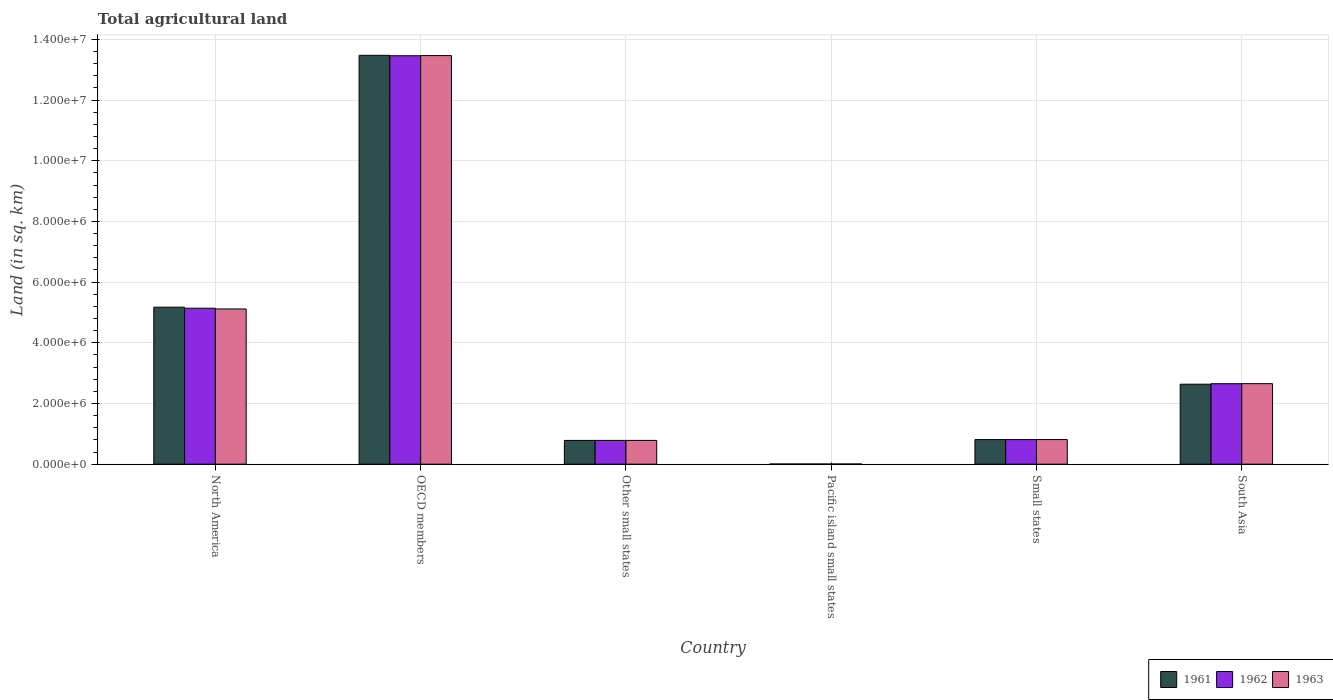How many different coloured bars are there?
Ensure brevity in your answer.  3. How many groups of bars are there?
Your response must be concise. 6. What is the label of the 2nd group of bars from the left?
Your response must be concise. OECD members. What is the total agricultural land in 1961 in South Asia?
Provide a short and direct response. 2.64e+06. Across all countries, what is the maximum total agricultural land in 1963?
Your answer should be compact. 1.35e+07. Across all countries, what is the minimum total agricultural land in 1962?
Your answer should be very brief. 5130. In which country was the total agricultural land in 1962 minimum?
Give a very brief answer. Pacific island small states. What is the total total agricultural land in 1963 in the graph?
Ensure brevity in your answer.  2.28e+07. What is the difference between the total agricultural land in 1962 in North America and that in Other small states?
Keep it short and to the point. 4.36e+06. What is the difference between the total agricultural land in 1962 in Small states and the total agricultural land in 1961 in OECD members?
Provide a succinct answer. -1.27e+07. What is the average total agricultural land in 1962 per country?
Your response must be concise. 3.81e+06. What is the difference between the total agricultural land of/in 1961 and total agricultural land of/in 1963 in North America?
Ensure brevity in your answer.  5.81e+04. In how many countries, is the total agricultural land in 1961 greater than 800000 sq.km?
Your response must be concise. 4. What is the ratio of the total agricultural land in 1961 in Pacific island small states to that in South Asia?
Your answer should be very brief. 0. Is the total agricultural land in 1962 in Pacific island small states less than that in South Asia?
Provide a succinct answer. Yes. What is the difference between the highest and the second highest total agricultural land in 1962?
Your response must be concise. -8.32e+06. What is the difference between the highest and the lowest total agricultural land in 1962?
Offer a very short reply. 1.35e+07. In how many countries, is the total agricultural land in 1961 greater than the average total agricultural land in 1961 taken over all countries?
Offer a very short reply. 2. What does the 1st bar from the left in South Asia represents?
Keep it short and to the point. 1961. Are the values on the major ticks of Y-axis written in scientific E-notation?
Your answer should be very brief. Yes. Does the graph contain any zero values?
Ensure brevity in your answer.  No. Where does the legend appear in the graph?
Make the answer very short. Bottom right. How many legend labels are there?
Your answer should be compact. 3. How are the legend labels stacked?
Give a very brief answer. Horizontal. What is the title of the graph?
Make the answer very short. Total agricultural land. What is the label or title of the Y-axis?
Ensure brevity in your answer.  Land (in sq. km). What is the Land (in sq. km) of 1961 in North America?
Your answer should be compact. 5.17e+06. What is the Land (in sq. km) of 1962 in North America?
Make the answer very short. 5.14e+06. What is the Land (in sq. km) in 1963 in North America?
Offer a very short reply. 5.12e+06. What is the Land (in sq. km) in 1961 in OECD members?
Provide a short and direct response. 1.35e+07. What is the Land (in sq. km) in 1962 in OECD members?
Your answer should be very brief. 1.35e+07. What is the Land (in sq. km) in 1963 in OECD members?
Give a very brief answer. 1.35e+07. What is the Land (in sq. km) in 1961 in Other small states?
Ensure brevity in your answer.  7.83e+05. What is the Land (in sq. km) of 1962 in Other small states?
Keep it short and to the point. 7.83e+05. What is the Land (in sq. km) in 1963 in Other small states?
Keep it short and to the point. 7.83e+05. What is the Land (in sq. km) of 1961 in Pacific island small states?
Offer a terse response. 5110. What is the Land (in sq. km) of 1962 in Pacific island small states?
Your response must be concise. 5130. What is the Land (in sq. km) of 1963 in Pacific island small states?
Provide a short and direct response. 5190. What is the Land (in sq. km) in 1961 in Small states?
Make the answer very short. 8.10e+05. What is the Land (in sq. km) in 1962 in Small states?
Make the answer very short. 8.11e+05. What is the Land (in sq. km) in 1963 in Small states?
Provide a short and direct response. 8.11e+05. What is the Land (in sq. km) of 1961 in South Asia?
Offer a very short reply. 2.64e+06. What is the Land (in sq. km) in 1962 in South Asia?
Keep it short and to the point. 2.65e+06. What is the Land (in sq. km) in 1963 in South Asia?
Ensure brevity in your answer.  2.65e+06. Across all countries, what is the maximum Land (in sq. km) in 1961?
Keep it short and to the point. 1.35e+07. Across all countries, what is the maximum Land (in sq. km) in 1962?
Make the answer very short. 1.35e+07. Across all countries, what is the maximum Land (in sq. km) of 1963?
Provide a short and direct response. 1.35e+07. Across all countries, what is the minimum Land (in sq. km) in 1961?
Your answer should be very brief. 5110. Across all countries, what is the minimum Land (in sq. km) of 1962?
Provide a short and direct response. 5130. Across all countries, what is the minimum Land (in sq. km) in 1963?
Offer a very short reply. 5190. What is the total Land (in sq. km) of 1961 in the graph?
Give a very brief answer. 2.29e+07. What is the total Land (in sq. km) of 1962 in the graph?
Offer a very short reply. 2.29e+07. What is the total Land (in sq. km) of 1963 in the graph?
Offer a terse response. 2.28e+07. What is the difference between the Land (in sq. km) in 1961 in North America and that in OECD members?
Your answer should be very brief. -8.30e+06. What is the difference between the Land (in sq. km) of 1962 in North America and that in OECD members?
Your answer should be very brief. -8.32e+06. What is the difference between the Land (in sq. km) in 1963 in North America and that in OECD members?
Your response must be concise. -8.35e+06. What is the difference between the Land (in sq. km) in 1961 in North America and that in Other small states?
Offer a very short reply. 4.39e+06. What is the difference between the Land (in sq. km) of 1962 in North America and that in Other small states?
Ensure brevity in your answer.  4.36e+06. What is the difference between the Land (in sq. km) in 1963 in North America and that in Other small states?
Your response must be concise. 4.33e+06. What is the difference between the Land (in sq. km) in 1961 in North America and that in Pacific island small states?
Provide a succinct answer. 5.17e+06. What is the difference between the Land (in sq. km) of 1962 in North America and that in Pacific island small states?
Offer a very short reply. 5.13e+06. What is the difference between the Land (in sq. km) of 1963 in North America and that in Pacific island small states?
Provide a short and direct response. 5.11e+06. What is the difference between the Land (in sq. km) in 1961 in North America and that in Small states?
Keep it short and to the point. 4.36e+06. What is the difference between the Land (in sq. km) of 1962 in North America and that in Small states?
Provide a short and direct response. 4.33e+06. What is the difference between the Land (in sq. km) in 1963 in North America and that in Small states?
Your answer should be very brief. 4.30e+06. What is the difference between the Land (in sq. km) in 1961 in North America and that in South Asia?
Offer a very short reply. 2.54e+06. What is the difference between the Land (in sq. km) of 1962 in North America and that in South Asia?
Your response must be concise. 2.49e+06. What is the difference between the Land (in sq. km) in 1963 in North America and that in South Asia?
Your answer should be very brief. 2.46e+06. What is the difference between the Land (in sq. km) in 1961 in OECD members and that in Other small states?
Make the answer very short. 1.27e+07. What is the difference between the Land (in sq. km) in 1962 in OECD members and that in Other small states?
Give a very brief answer. 1.27e+07. What is the difference between the Land (in sq. km) of 1963 in OECD members and that in Other small states?
Your answer should be very brief. 1.27e+07. What is the difference between the Land (in sq. km) in 1961 in OECD members and that in Pacific island small states?
Make the answer very short. 1.35e+07. What is the difference between the Land (in sq. km) of 1962 in OECD members and that in Pacific island small states?
Keep it short and to the point. 1.35e+07. What is the difference between the Land (in sq. km) of 1963 in OECD members and that in Pacific island small states?
Provide a succinct answer. 1.35e+07. What is the difference between the Land (in sq. km) in 1961 in OECD members and that in Small states?
Ensure brevity in your answer.  1.27e+07. What is the difference between the Land (in sq. km) in 1962 in OECD members and that in Small states?
Provide a short and direct response. 1.27e+07. What is the difference between the Land (in sq. km) in 1963 in OECD members and that in Small states?
Provide a short and direct response. 1.27e+07. What is the difference between the Land (in sq. km) of 1961 in OECD members and that in South Asia?
Your answer should be compact. 1.08e+07. What is the difference between the Land (in sq. km) in 1962 in OECD members and that in South Asia?
Give a very brief answer. 1.08e+07. What is the difference between the Land (in sq. km) in 1963 in OECD members and that in South Asia?
Provide a short and direct response. 1.08e+07. What is the difference between the Land (in sq. km) in 1961 in Other small states and that in Pacific island small states?
Offer a very short reply. 7.78e+05. What is the difference between the Land (in sq. km) of 1962 in Other small states and that in Pacific island small states?
Offer a very short reply. 7.78e+05. What is the difference between the Land (in sq. km) in 1963 in Other small states and that in Pacific island small states?
Provide a succinct answer. 7.78e+05. What is the difference between the Land (in sq. km) in 1961 in Other small states and that in Small states?
Offer a very short reply. -2.74e+04. What is the difference between the Land (in sq. km) in 1962 in Other small states and that in Small states?
Your response must be concise. -2.75e+04. What is the difference between the Land (in sq. km) in 1963 in Other small states and that in Small states?
Your answer should be compact. -2.76e+04. What is the difference between the Land (in sq. km) of 1961 in Other small states and that in South Asia?
Offer a terse response. -1.85e+06. What is the difference between the Land (in sq. km) of 1962 in Other small states and that in South Asia?
Make the answer very short. -1.87e+06. What is the difference between the Land (in sq. km) of 1963 in Other small states and that in South Asia?
Offer a terse response. -1.87e+06. What is the difference between the Land (in sq. km) of 1961 in Pacific island small states and that in Small states?
Your response must be concise. -8.05e+05. What is the difference between the Land (in sq. km) of 1962 in Pacific island small states and that in Small states?
Ensure brevity in your answer.  -8.05e+05. What is the difference between the Land (in sq. km) in 1963 in Pacific island small states and that in Small states?
Your answer should be compact. -8.06e+05. What is the difference between the Land (in sq. km) of 1961 in Pacific island small states and that in South Asia?
Your answer should be very brief. -2.63e+06. What is the difference between the Land (in sq. km) of 1962 in Pacific island small states and that in South Asia?
Your answer should be compact. -2.65e+06. What is the difference between the Land (in sq. km) of 1963 in Pacific island small states and that in South Asia?
Offer a terse response. -2.65e+06. What is the difference between the Land (in sq. km) in 1961 in Small states and that in South Asia?
Your answer should be compact. -1.82e+06. What is the difference between the Land (in sq. km) of 1962 in Small states and that in South Asia?
Ensure brevity in your answer.  -1.84e+06. What is the difference between the Land (in sq. km) of 1963 in Small states and that in South Asia?
Ensure brevity in your answer.  -1.84e+06. What is the difference between the Land (in sq. km) of 1961 in North America and the Land (in sq. km) of 1962 in OECD members?
Your response must be concise. -8.29e+06. What is the difference between the Land (in sq. km) of 1961 in North America and the Land (in sq. km) of 1963 in OECD members?
Provide a succinct answer. -8.29e+06. What is the difference between the Land (in sq. km) of 1962 in North America and the Land (in sq. km) of 1963 in OECD members?
Your response must be concise. -8.33e+06. What is the difference between the Land (in sq. km) in 1961 in North America and the Land (in sq. km) in 1962 in Other small states?
Keep it short and to the point. 4.39e+06. What is the difference between the Land (in sq. km) of 1961 in North America and the Land (in sq. km) of 1963 in Other small states?
Keep it short and to the point. 4.39e+06. What is the difference between the Land (in sq. km) in 1962 in North America and the Land (in sq. km) in 1963 in Other small states?
Your answer should be compact. 4.36e+06. What is the difference between the Land (in sq. km) of 1961 in North America and the Land (in sq. km) of 1962 in Pacific island small states?
Offer a very short reply. 5.17e+06. What is the difference between the Land (in sq. km) in 1961 in North America and the Land (in sq. km) in 1963 in Pacific island small states?
Your answer should be very brief. 5.17e+06. What is the difference between the Land (in sq. km) of 1962 in North America and the Land (in sq. km) of 1963 in Pacific island small states?
Provide a short and direct response. 5.13e+06. What is the difference between the Land (in sq. km) of 1961 in North America and the Land (in sq. km) of 1962 in Small states?
Your response must be concise. 4.36e+06. What is the difference between the Land (in sq. km) in 1961 in North America and the Land (in sq. km) in 1963 in Small states?
Make the answer very short. 4.36e+06. What is the difference between the Land (in sq. km) in 1962 in North America and the Land (in sq. km) in 1963 in Small states?
Offer a terse response. 4.33e+06. What is the difference between the Land (in sq. km) of 1961 in North America and the Land (in sq. km) of 1962 in South Asia?
Offer a terse response. 2.52e+06. What is the difference between the Land (in sq. km) in 1961 in North America and the Land (in sq. km) in 1963 in South Asia?
Offer a terse response. 2.52e+06. What is the difference between the Land (in sq. km) of 1962 in North America and the Land (in sq. km) of 1963 in South Asia?
Keep it short and to the point. 2.49e+06. What is the difference between the Land (in sq. km) of 1961 in OECD members and the Land (in sq. km) of 1962 in Other small states?
Provide a succinct answer. 1.27e+07. What is the difference between the Land (in sq. km) in 1961 in OECD members and the Land (in sq. km) in 1963 in Other small states?
Keep it short and to the point. 1.27e+07. What is the difference between the Land (in sq. km) of 1962 in OECD members and the Land (in sq. km) of 1963 in Other small states?
Your answer should be very brief. 1.27e+07. What is the difference between the Land (in sq. km) in 1961 in OECD members and the Land (in sq. km) in 1962 in Pacific island small states?
Offer a very short reply. 1.35e+07. What is the difference between the Land (in sq. km) of 1961 in OECD members and the Land (in sq. km) of 1963 in Pacific island small states?
Your answer should be compact. 1.35e+07. What is the difference between the Land (in sq. km) in 1962 in OECD members and the Land (in sq. km) in 1963 in Pacific island small states?
Your answer should be compact. 1.35e+07. What is the difference between the Land (in sq. km) of 1961 in OECD members and the Land (in sq. km) of 1962 in Small states?
Give a very brief answer. 1.27e+07. What is the difference between the Land (in sq. km) in 1961 in OECD members and the Land (in sq. km) in 1963 in Small states?
Make the answer very short. 1.27e+07. What is the difference between the Land (in sq. km) in 1962 in OECD members and the Land (in sq. km) in 1963 in Small states?
Ensure brevity in your answer.  1.27e+07. What is the difference between the Land (in sq. km) of 1961 in OECD members and the Land (in sq. km) of 1962 in South Asia?
Offer a terse response. 1.08e+07. What is the difference between the Land (in sq. km) of 1961 in OECD members and the Land (in sq. km) of 1963 in South Asia?
Your answer should be very brief. 1.08e+07. What is the difference between the Land (in sq. km) in 1962 in OECD members and the Land (in sq. km) in 1963 in South Asia?
Make the answer very short. 1.08e+07. What is the difference between the Land (in sq. km) in 1961 in Other small states and the Land (in sq. km) in 1962 in Pacific island small states?
Provide a short and direct response. 7.78e+05. What is the difference between the Land (in sq. km) in 1961 in Other small states and the Land (in sq. km) in 1963 in Pacific island small states?
Give a very brief answer. 7.78e+05. What is the difference between the Land (in sq. km) in 1962 in Other small states and the Land (in sq. km) in 1963 in Pacific island small states?
Keep it short and to the point. 7.78e+05. What is the difference between the Land (in sq. km) in 1961 in Other small states and the Land (in sq. km) in 1962 in Small states?
Your answer should be very brief. -2.78e+04. What is the difference between the Land (in sq. km) of 1961 in Other small states and the Land (in sq. km) of 1963 in Small states?
Offer a very short reply. -2.80e+04. What is the difference between the Land (in sq. km) in 1962 in Other small states and the Land (in sq. km) in 1963 in Small states?
Provide a short and direct response. -2.78e+04. What is the difference between the Land (in sq. km) in 1961 in Other small states and the Land (in sq. km) in 1962 in South Asia?
Ensure brevity in your answer.  -1.87e+06. What is the difference between the Land (in sq. km) in 1961 in Other small states and the Land (in sq. km) in 1963 in South Asia?
Your response must be concise. -1.87e+06. What is the difference between the Land (in sq. km) of 1962 in Other small states and the Land (in sq. km) of 1963 in South Asia?
Give a very brief answer. -1.87e+06. What is the difference between the Land (in sq. km) of 1961 in Pacific island small states and the Land (in sq. km) of 1962 in Small states?
Your answer should be compact. -8.05e+05. What is the difference between the Land (in sq. km) of 1961 in Pacific island small states and the Land (in sq. km) of 1963 in Small states?
Your response must be concise. -8.06e+05. What is the difference between the Land (in sq. km) of 1962 in Pacific island small states and the Land (in sq. km) of 1963 in Small states?
Provide a succinct answer. -8.06e+05. What is the difference between the Land (in sq. km) of 1961 in Pacific island small states and the Land (in sq. km) of 1962 in South Asia?
Provide a short and direct response. -2.65e+06. What is the difference between the Land (in sq. km) of 1961 in Pacific island small states and the Land (in sq. km) of 1963 in South Asia?
Provide a succinct answer. -2.65e+06. What is the difference between the Land (in sq. km) of 1962 in Pacific island small states and the Land (in sq. km) of 1963 in South Asia?
Keep it short and to the point. -2.65e+06. What is the difference between the Land (in sq. km) of 1961 in Small states and the Land (in sq. km) of 1962 in South Asia?
Provide a short and direct response. -1.84e+06. What is the difference between the Land (in sq. km) of 1961 in Small states and the Land (in sq. km) of 1963 in South Asia?
Your answer should be compact. -1.84e+06. What is the difference between the Land (in sq. km) in 1962 in Small states and the Land (in sq. km) in 1963 in South Asia?
Your answer should be compact. -1.84e+06. What is the average Land (in sq. km) in 1961 per country?
Your response must be concise. 3.81e+06. What is the average Land (in sq. km) of 1962 per country?
Ensure brevity in your answer.  3.81e+06. What is the average Land (in sq. km) of 1963 per country?
Offer a very short reply. 3.81e+06. What is the difference between the Land (in sq. km) in 1961 and Land (in sq. km) in 1962 in North America?
Make the answer very short. 3.39e+04. What is the difference between the Land (in sq. km) in 1961 and Land (in sq. km) in 1963 in North America?
Your response must be concise. 5.81e+04. What is the difference between the Land (in sq. km) in 1962 and Land (in sq. km) in 1963 in North America?
Your answer should be compact. 2.42e+04. What is the difference between the Land (in sq. km) in 1961 and Land (in sq. km) in 1962 in OECD members?
Your answer should be compact. 1.42e+04. What is the difference between the Land (in sq. km) of 1961 and Land (in sq. km) of 1963 in OECD members?
Your answer should be very brief. 8693. What is the difference between the Land (in sq. km) of 1962 and Land (in sq. km) of 1963 in OECD members?
Make the answer very short. -5492. What is the difference between the Land (in sq. km) of 1961 and Land (in sq. km) of 1962 in Other small states?
Offer a very short reply. -290. What is the difference between the Land (in sq. km) of 1961 and Land (in sq. km) of 1963 in Other small states?
Provide a short and direct response. -460. What is the difference between the Land (in sq. km) of 1962 and Land (in sq. km) of 1963 in Other small states?
Ensure brevity in your answer.  -170. What is the difference between the Land (in sq. km) in 1961 and Land (in sq. km) in 1962 in Pacific island small states?
Make the answer very short. -20. What is the difference between the Land (in sq. km) of 1961 and Land (in sq. km) of 1963 in Pacific island small states?
Offer a terse response. -80. What is the difference between the Land (in sq. km) of 1962 and Land (in sq. km) of 1963 in Pacific island small states?
Your answer should be compact. -60. What is the difference between the Land (in sq. km) in 1961 and Land (in sq. km) in 1962 in Small states?
Keep it short and to the point. -340. What is the difference between the Land (in sq. km) of 1961 and Land (in sq. km) of 1963 in Small states?
Provide a short and direct response. -600. What is the difference between the Land (in sq. km) of 1962 and Land (in sq. km) of 1963 in Small states?
Your answer should be compact. -260. What is the difference between the Land (in sq. km) in 1961 and Land (in sq. km) in 1962 in South Asia?
Offer a terse response. -1.68e+04. What is the difference between the Land (in sq. km) of 1961 and Land (in sq. km) of 1963 in South Asia?
Keep it short and to the point. -1.81e+04. What is the difference between the Land (in sq. km) in 1962 and Land (in sq. km) in 1963 in South Asia?
Provide a succinct answer. -1280. What is the ratio of the Land (in sq. km) in 1961 in North America to that in OECD members?
Your answer should be compact. 0.38. What is the ratio of the Land (in sq. km) in 1962 in North America to that in OECD members?
Your answer should be very brief. 0.38. What is the ratio of the Land (in sq. km) of 1963 in North America to that in OECD members?
Your answer should be compact. 0.38. What is the ratio of the Land (in sq. km) of 1961 in North America to that in Other small states?
Offer a terse response. 6.61. What is the ratio of the Land (in sq. km) in 1962 in North America to that in Other small states?
Make the answer very short. 6.56. What is the ratio of the Land (in sq. km) in 1963 in North America to that in Other small states?
Offer a very short reply. 6.53. What is the ratio of the Land (in sq. km) of 1961 in North America to that in Pacific island small states?
Give a very brief answer. 1012.4. What is the ratio of the Land (in sq. km) in 1962 in North America to that in Pacific island small states?
Your response must be concise. 1001.84. What is the ratio of the Land (in sq. km) in 1963 in North America to that in Pacific island small states?
Ensure brevity in your answer.  985.6. What is the ratio of the Land (in sq. km) of 1961 in North America to that in Small states?
Provide a short and direct response. 6.38. What is the ratio of the Land (in sq. km) of 1962 in North America to that in Small states?
Your answer should be compact. 6.34. What is the ratio of the Land (in sq. km) in 1963 in North America to that in Small states?
Your answer should be very brief. 6.31. What is the ratio of the Land (in sq. km) of 1961 in North America to that in South Asia?
Offer a very short reply. 1.96. What is the ratio of the Land (in sq. km) in 1962 in North America to that in South Asia?
Your answer should be very brief. 1.94. What is the ratio of the Land (in sq. km) of 1963 in North America to that in South Asia?
Give a very brief answer. 1.93. What is the ratio of the Land (in sq. km) in 1961 in OECD members to that in Other small states?
Give a very brief answer. 17.21. What is the ratio of the Land (in sq. km) of 1962 in OECD members to that in Other small states?
Your answer should be compact. 17.19. What is the ratio of the Land (in sq. km) of 1963 in OECD members to that in Other small states?
Provide a succinct answer. 17.19. What is the ratio of the Land (in sq. km) of 1961 in OECD members to that in Pacific island small states?
Provide a short and direct response. 2637.03. What is the ratio of the Land (in sq. km) of 1962 in OECD members to that in Pacific island small states?
Keep it short and to the point. 2623.99. What is the ratio of the Land (in sq. km) of 1963 in OECD members to that in Pacific island small states?
Offer a terse response. 2594.71. What is the ratio of the Land (in sq. km) of 1961 in OECD members to that in Small states?
Keep it short and to the point. 16.63. What is the ratio of the Land (in sq. km) in 1962 in OECD members to that in Small states?
Keep it short and to the point. 16.61. What is the ratio of the Land (in sq. km) of 1963 in OECD members to that in Small states?
Ensure brevity in your answer.  16.61. What is the ratio of the Land (in sq. km) in 1961 in OECD members to that in South Asia?
Provide a short and direct response. 5.11. What is the ratio of the Land (in sq. km) in 1962 in OECD members to that in South Asia?
Make the answer very short. 5.08. What is the ratio of the Land (in sq. km) of 1963 in OECD members to that in South Asia?
Ensure brevity in your answer.  5.08. What is the ratio of the Land (in sq. km) in 1961 in Other small states to that in Pacific island small states?
Give a very brief answer. 153.19. What is the ratio of the Land (in sq. km) of 1962 in Other small states to that in Pacific island small states?
Provide a short and direct response. 152.65. What is the ratio of the Land (in sq. km) in 1963 in Other small states to that in Pacific island small states?
Give a very brief answer. 150.91. What is the ratio of the Land (in sq. km) of 1961 in Other small states to that in Small states?
Ensure brevity in your answer.  0.97. What is the ratio of the Land (in sq. km) in 1962 in Other small states to that in Small states?
Your response must be concise. 0.97. What is the ratio of the Land (in sq. km) in 1961 in Other small states to that in South Asia?
Provide a succinct answer. 0.3. What is the ratio of the Land (in sq. km) in 1962 in Other small states to that in South Asia?
Ensure brevity in your answer.  0.3. What is the ratio of the Land (in sq. km) of 1963 in Other small states to that in South Asia?
Make the answer very short. 0.3. What is the ratio of the Land (in sq. km) of 1961 in Pacific island small states to that in Small states?
Keep it short and to the point. 0.01. What is the ratio of the Land (in sq. km) in 1962 in Pacific island small states to that in Small states?
Keep it short and to the point. 0.01. What is the ratio of the Land (in sq. km) of 1963 in Pacific island small states to that in Small states?
Your answer should be compact. 0.01. What is the ratio of the Land (in sq. km) in 1961 in Pacific island small states to that in South Asia?
Provide a succinct answer. 0. What is the ratio of the Land (in sq. km) of 1962 in Pacific island small states to that in South Asia?
Keep it short and to the point. 0. What is the ratio of the Land (in sq. km) of 1963 in Pacific island small states to that in South Asia?
Make the answer very short. 0. What is the ratio of the Land (in sq. km) in 1961 in Small states to that in South Asia?
Your answer should be very brief. 0.31. What is the ratio of the Land (in sq. km) in 1962 in Small states to that in South Asia?
Provide a short and direct response. 0.31. What is the ratio of the Land (in sq. km) of 1963 in Small states to that in South Asia?
Give a very brief answer. 0.31. What is the difference between the highest and the second highest Land (in sq. km) in 1961?
Keep it short and to the point. 8.30e+06. What is the difference between the highest and the second highest Land (in sq. km) of 1962?
Offer a very short reply. 8.32e+06. What is the difference between the highest and the second highest Land (in sq. km) of 1963?
Your answer should be very brief. 8.35e+06. What is the difference between the highest and the lowest Land (in sq. km) in 1961?
Your answer should be very brief. 1.35e+07. What is the difference between the highest and the lowest Land (in sq. km) in 1962?
Your response must be concise. 1.35e+07. What is the difference between the highest and the lowest Land (in sq. km) in 1963?
Provide a short and direct response. 1.35e+07. 